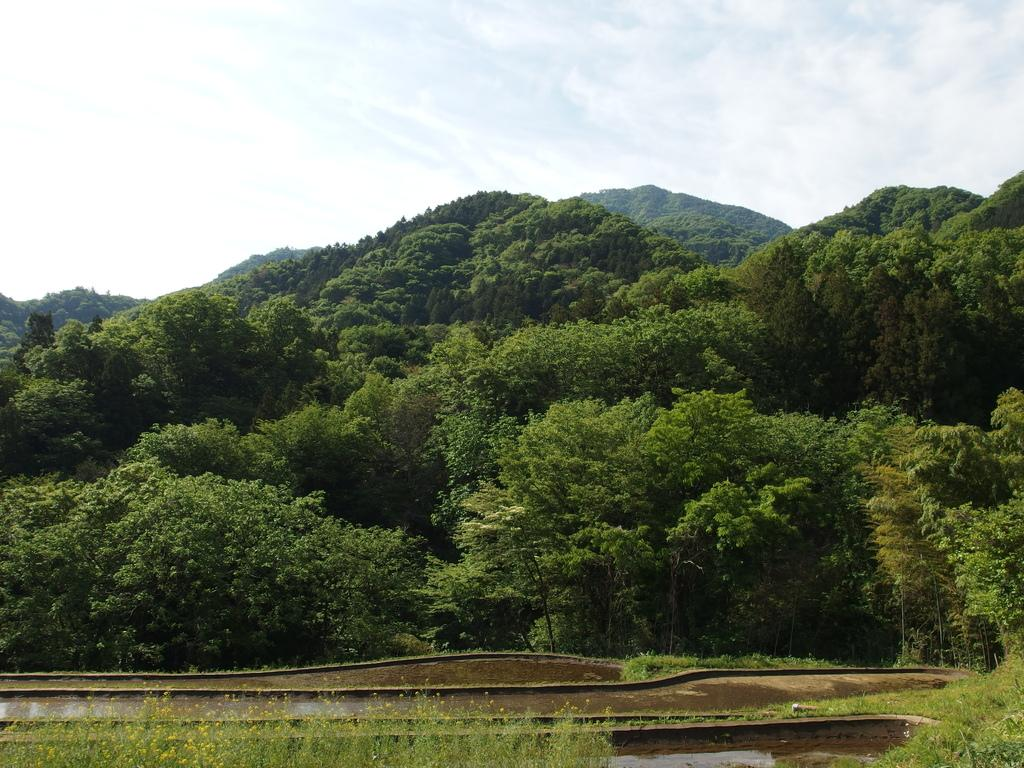What is located in the center of the image? There are trees in the center of the image. What can be seen at the bottom of the image? There is water at the bottom of the image. What type of vegetation is visible in the image? There are plants visible in the image. What can be seen in the background of the image? There are hills and the sky visible in the background of the image. What type of apparatus is being used by the doctor in the image? There is no doctor or apparatus present in the image. What argument is being discussed by the people near the water in the image? There are no people or arguments present in the image; it features trees, water, plants, hills, and the sky. 